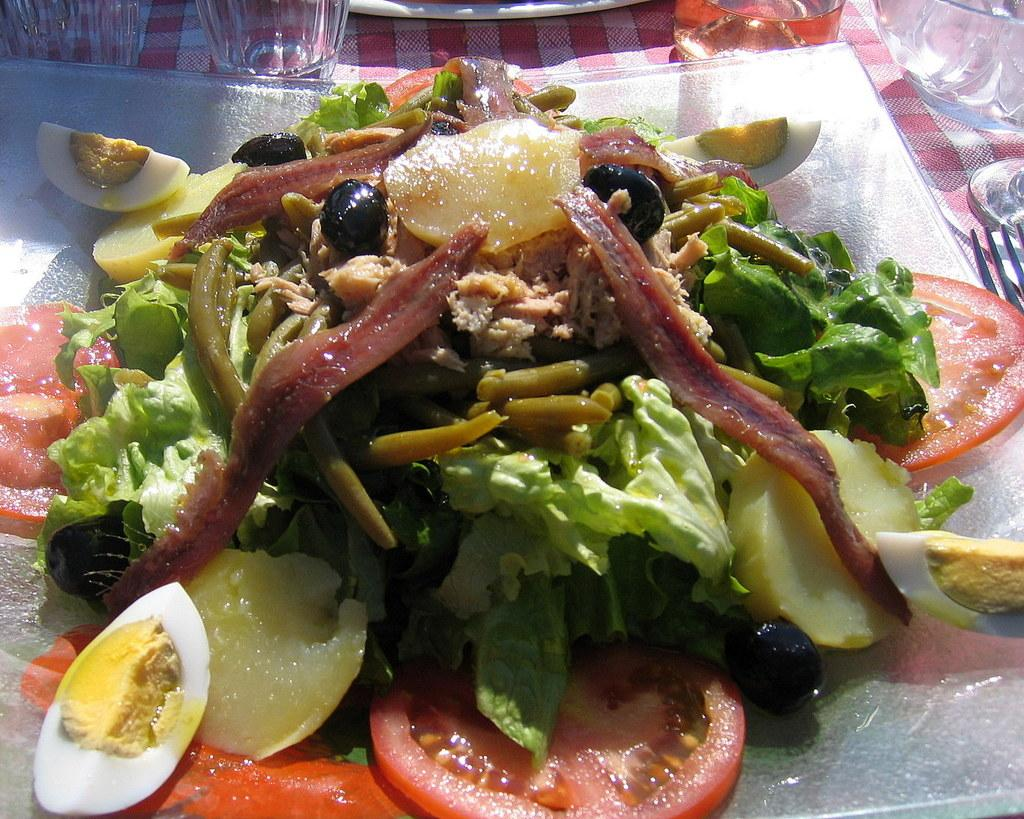What is on the plate that is visible in the image? There are food items on a plate in the image. What else can be seen in the image besides the plate? There are glasses and a bowl in the image. What might be used for holding liquids in the image? The glasses in the image can be used for holding liquids. What other objects are present on a cloth in the image? There are other objects on a cloth in the image, but their specific details are not mentioned in the provided facts. What type of stone can be seen in the image? There is no stone present in the image. What does the image smell like? The image does not have a smell, as it is a visual representation. 